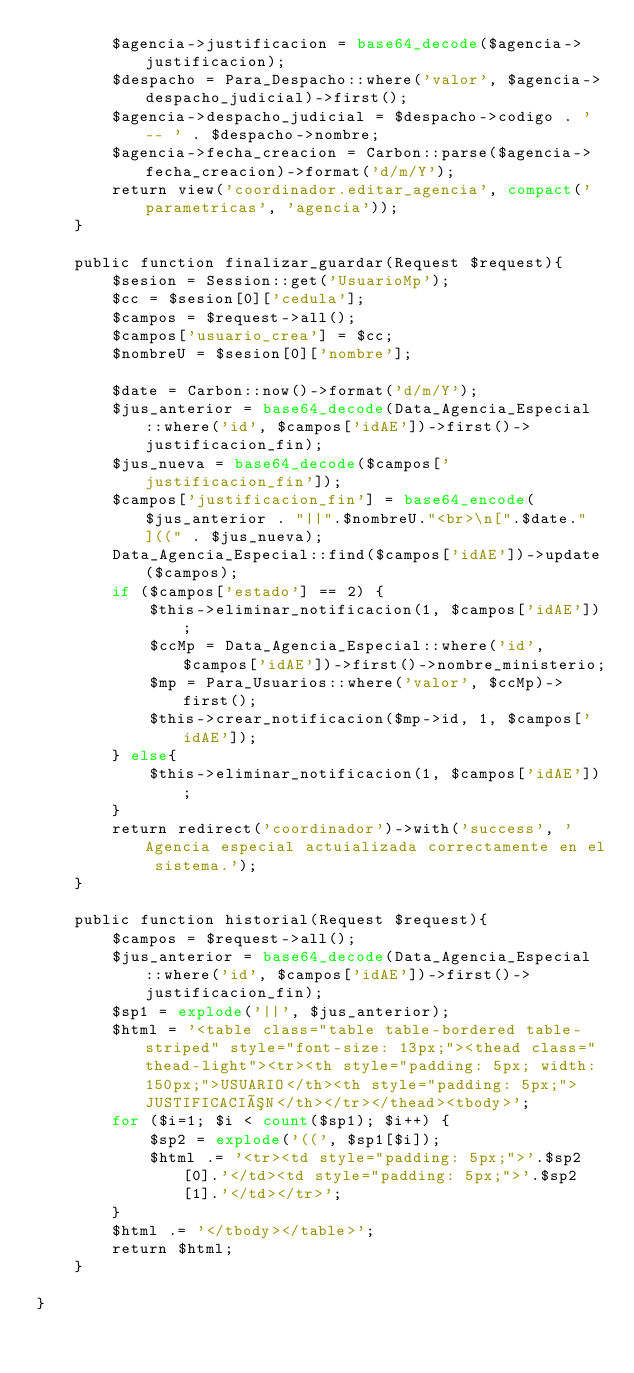Convert code to text. <code><loc_0><loc_0><loc_500><loc_500><_PHP_>        $agencia->justificacion = base64_decode($agencia->justificacion);
        $despacho = Para_Despacho::where('valor', $agencia->despacho_judicial)->first();
        $agencia->despacho_judicial = $despacho->codigo . ' -- ' . $despacho->nombre;
        $agencia->fecha_creacion = Carbon::parse($agencia->fecha_creacion)->format('d/m/Y');
        return view('coordinador.editar_agencia', compact('parametricas', 'agencia'));
    }

    public function finalizar_guardar(Request $request){
        $sesion = Session::get('UsuarioMp');
        $cc = $sesion[0]['cedula'];
        $campos = $request->all();
        $campos['usuario_crea'] = $cc;
        $nombreU = $sesion[0]['nombre'];

        $date = Carbon::now()->format('d/m/Y');
        $jus_anterior = base64_decode(Data_Agencia_Especial::where('id', $campos['idAE'])->first()->justificacion_fin);
        $jus_nueva = base64_decode($campos['justificacion_fin']);
        $campos['justificacion_fin'] = base64_encode($jus_anterior . "||".$nombreU."<br>\n[".$date."]((" . $jus_nueva);
        Data_Agencia_Especial::find($campos['idAE'])->update($campos);
        if ($campos['estado'] == 2) {
            $this->eliminar_notificacion(1, $campos['idAE']);
            $ccMp = Data_Agencia_Especial::where('id', $campos['idAE'])->first()->nombre_ministerio;
            $mp = Para_Usuarios::where('valor', $ccMp)->first();
            $this->crear_notificacion($mp->id, 1, $campos['idAE']);
        } else{
            $this->eliminar_notificacion(1, $campos['idAE']);
        }
        return redirect('coordinador')->with('success', 'Agencia especial actuializada correctamente en el sistema.');
    }

    public function historial(Request $request){
        $campos = $request->all();
        $jus_anterior = base64_decode(Data_Agencia_Especial::where('id', $campos['idAE'])->first()->justificacion_fin);
        $sp1 = explode('||', $jus_anterior);
        $html = '<table class="table table-bordered table-striped" style="font-size: 13px;"><thead class="thead-light"><tr><th style="padding: 5px; width: 150px;">USUARIO</th><th style="padding: 5px;">JUSTIFICACIÓN</th></tr></thead><tbody>';
        for ($i=1; $i < count($sp1); $i++) { 
            $sp2 = explode('((', $sp1[$i]);
            $html .= '<tr><td style="padding: 5px;">'.$sp2[0].'</td><td style="padding: 5px;">'.$sp2[1].'</td></tr>';
        }
        $html .= '</tbody></table>';
        return $html;
    }

}
</code> 